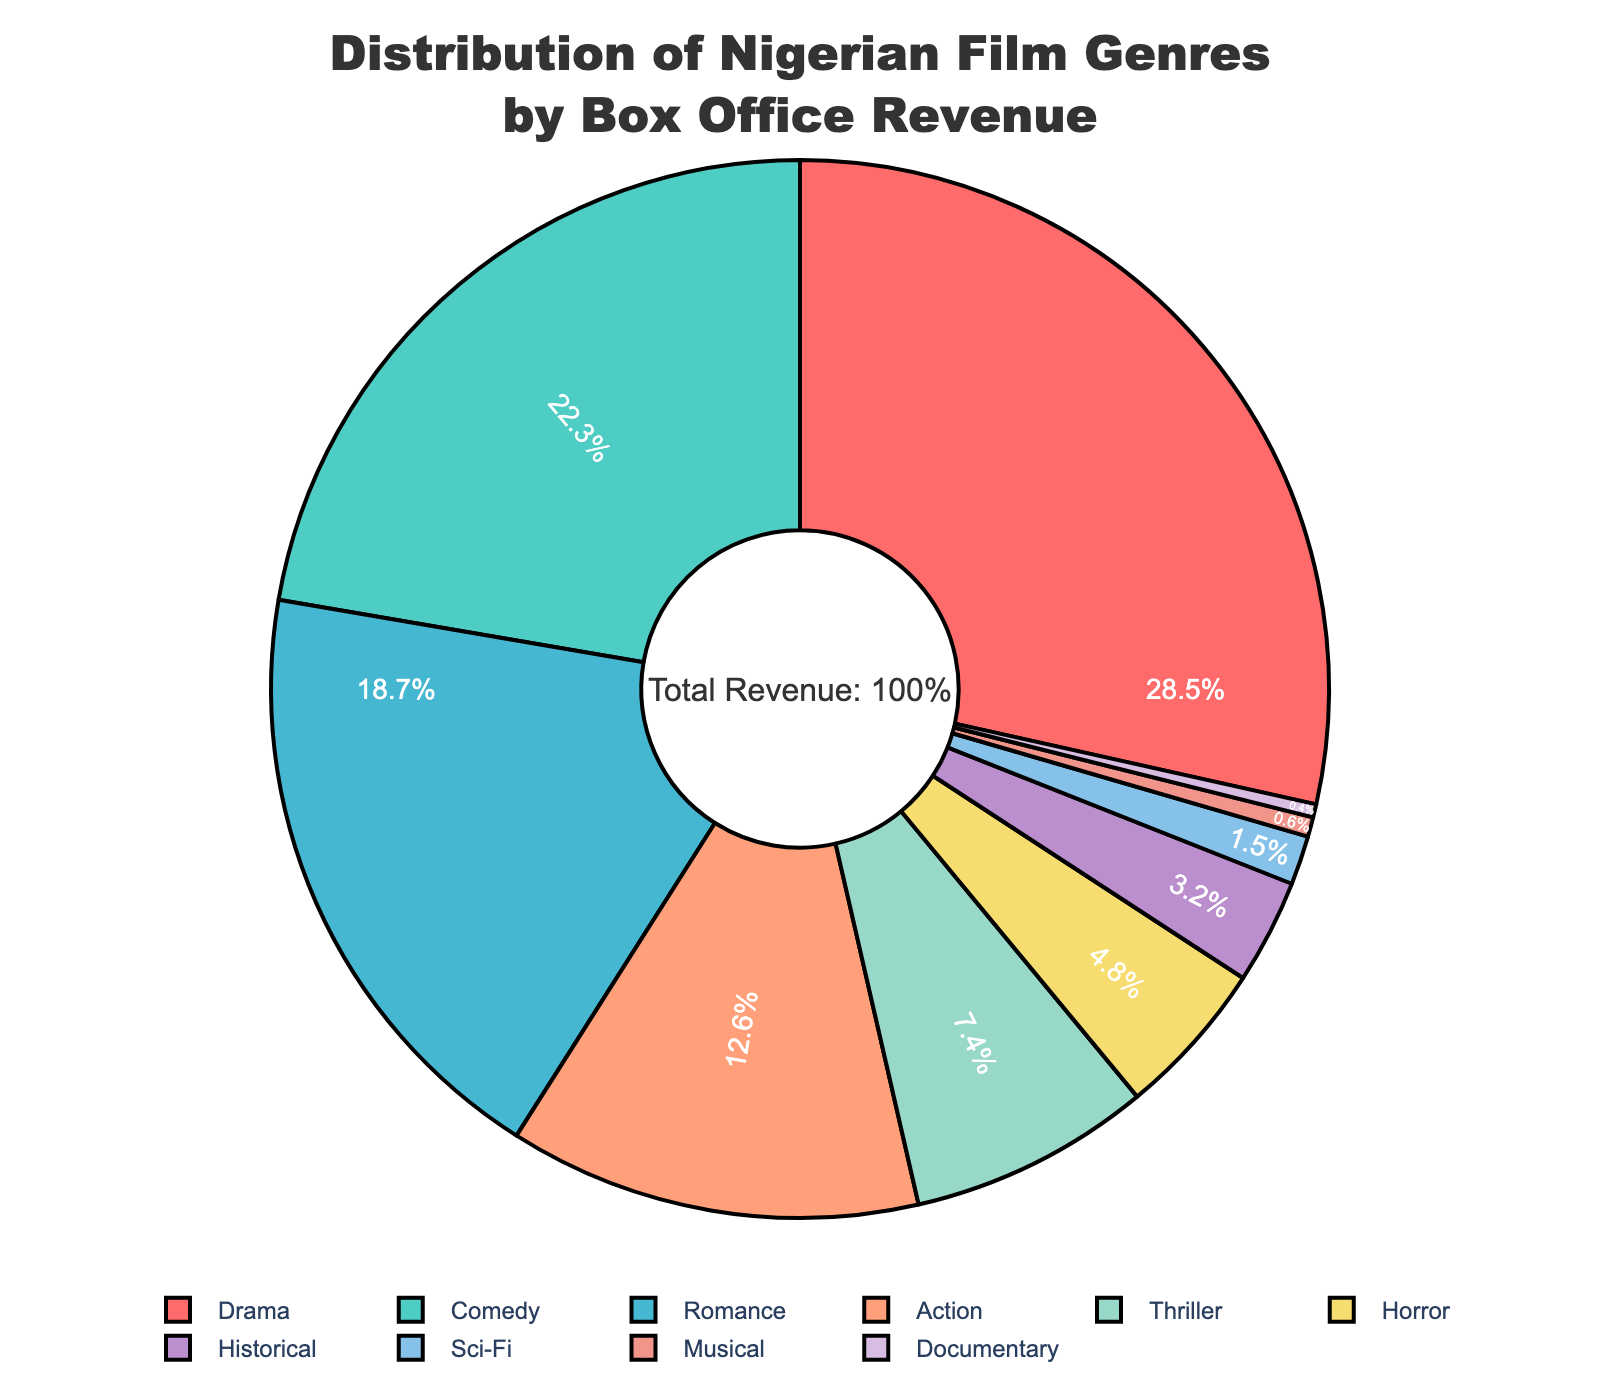what genre holds the highest revenue percentage? The genre with the largest slice of the pie chart is Drama, which holds the highest revenue percentage.
Answer: Drama how much more revenue does Comedy generate compared to Action? Comedy has a 22.3% revenue share and Action has a 12.6% share. The difference is 22.3% - 12.6% = 9.7%.
Answer: 9.7% which genres collectively make up less than 10% of the total revenue? By observing the smaller sections of the pie chart, Horror, Historical, Sci-Fi, Musical, and Documentary collectively make up less than 10% of the total revenue. Adding their percentages: 4.8% + 3.2% + 1.5% + 0.6% + 0.4% = 10.5%, which rounds down to < 10% collectively
Answer: Horror, Historical, Sci-Fi, Musical, and Documentary which genre has approximately double the revenue percentage of Thriller? Thriller has a 7.4% revenue percentage. Double this would be around 14.8%. Observing the pie chart, Drama (28.5%) is more than double, while Romance (18.7%) is closer but exceeds that. No genre fits exactly double.
Answer: None what are the genres between 10% and 20% revenue share? Scanning the pie chart for slices that fall between 10% and 20%, we find Action (12.6%) and Romance (18.7%). These are the genres within this range.
Answer: Action, Romance which genre has the second lowest revenue percentage? Examining the smallest slices of the pie chart, the genre with the second lowest revenue percentage is Musical with 0.6%.
Answer: Musical what percentage of revenue does the sum of Comedy and Romance represent? Comedy has a 22.3% share and Romance a 18.7%. Summing them up: 22.3% + 18.7% = 41%.
Answer: 41% which genres have revenue percentages that are at least 5 percentage points apart from each other? Genres need a minimum 5% difference. Examining pairs, Drama (28.5%) and Comedy (22.3%) differ by 6.2%, Comedy and Romance (18.7%) differ by 3.6%, so on. Concluding, notable pairs include Drama-Comedy, Comedy-Action, and Action-Romance, among others.
Answer: Drama-Comedy, Comedy-Action, Action-Romance among Horror, Historical, and Sci-Fi, which genre has the highest revenue percentage? By comparing these genres on the pie chart, Horror has 4.8%, Historical has 3.2%, and Sci-Fi has 1.5%.
Answer: Horror 